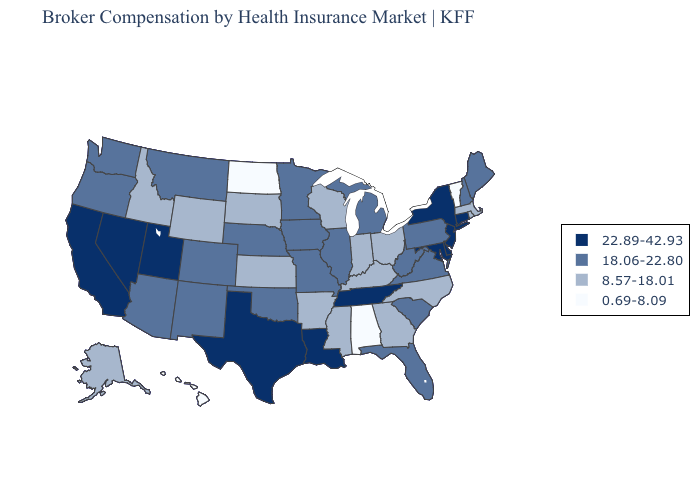What is the value of Utah?
Short answer required. 22.89-42.93. What is the lowest value in the USA?
Be succinct. 0.69-8.09. What is the highest value in the MidWest ?
Be succinct. 18.06-22.80. Does Iowa have a higher value than Michigan?
Concise answer only. No. Among the states that border Florida , does Georgia have the highest value?
Answer briefly. Yes. Among the states that border Arkansas , which have the lowest value?
Write a very short answer. Mississippi. Among the states that border Mississippi , does Alabama have the lowest value?
Concise answer only. Yes. Does the first symbol in the legend represent the smallest category?
Give a very brief answer. No. How many symbols are there in the legend?
Answer briefly. 4. Which states hav the highest value in the Northeast?
Give a very brief answer. Connecticut, New Jersey, New York. What is the value of Louisiana?
Quick response, please. 22.89-42.93. Is the legend a continuous bar?
Keep it brief. No. What is the highest value in the USA?
Give a very brief answer. 22.89-42.93. Name the states that have a value in the range 18.06-22.80?
Answer briefly. Arizona, Colorado, Florida, Illinois, Iowa, Maine, Michigan, Minnesota, Missouri, Montana, Nebraska, New Hampshire, New Mexico, Oklahoma, Oregon, Pennsylvania, South Carolina, Virginia, Washington, West Virginia. Does Tennessee have the highest value in the USA?
Answer briefly. Yes. 